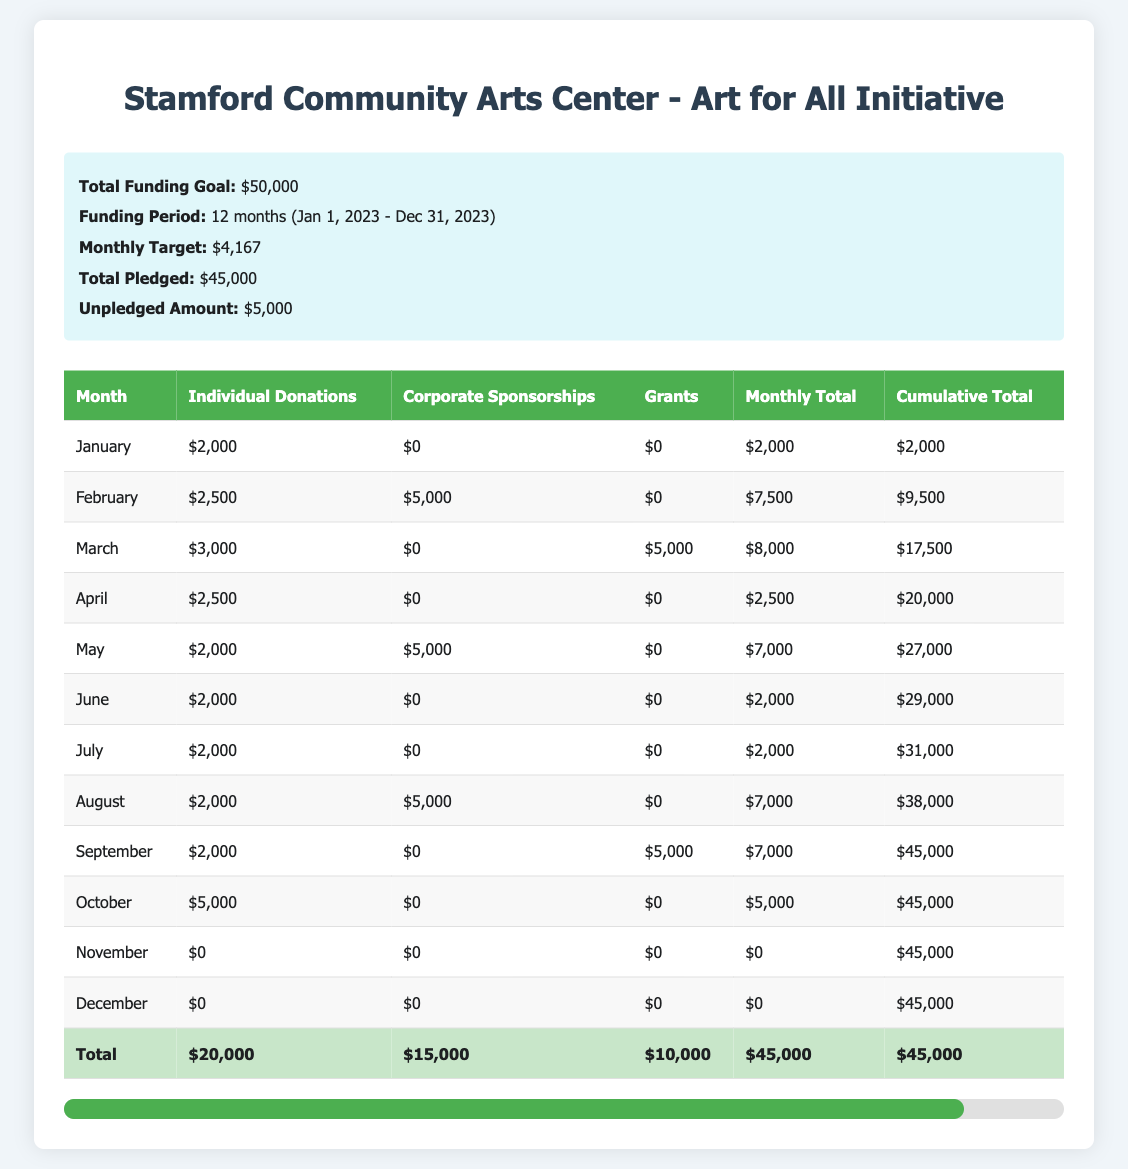What is the total amount pledged from Individual Donations? The total amount pledged from Individual Donations is listed in the last row of the "Individual Donations" column, which shows $20,000.
Answer: 20000 How much funding is expected in February? For February, the amounts from Individual Donations ($2,500), Corporate Sponsorships ($5,000), and Grants ($0) are totaled: 2,500 + 5,000 + 0 = 7,500.
Answer: 7500 Did the campaign reach its total funding goal of $50,000 by the end of the year? The total amount pledged is $45,000, which is less than the funding goal of $50,000, indicating that the campaign did not reach its goal.
Answer: No What was the cumulative total by the end of August? The cumulative total by the end of August can be found in the last row for August, which states $38,000.
Answer: 38000 How many months did it take to reach $27,000 in funding? By checking the cumulative total for each month, $27,000 was reached by the end of May. This means it took five months (January to May).
Answer: 5 Which month had the highest total funding, and what was that amount? The highest total funding was in March, with an amount of $8,000. This can be seen directly in the monthly totals.
Answer: 8000 What is the average monthly funding from Corporate Sponsorships? To find the average, sum the amounts received from Corporate Sponsorships ($15,000 total) and divide by the number of months it was received (3 months): 15,000 / 3 = 5,000.
Answer: 5000 From which funding source and in which month was the highest amount received? The highest amount received was $5,000 from Individual Donations in October. This is observed in the respective month and column.
Answer: October from Individual Donations What was the total fundraising received by the mid-year (end of June)? By checking the cumulative total in June, the total fundraising by the end of June was $29,000, which aggregates the amounts received monthly until that point.
Answer: 29000 